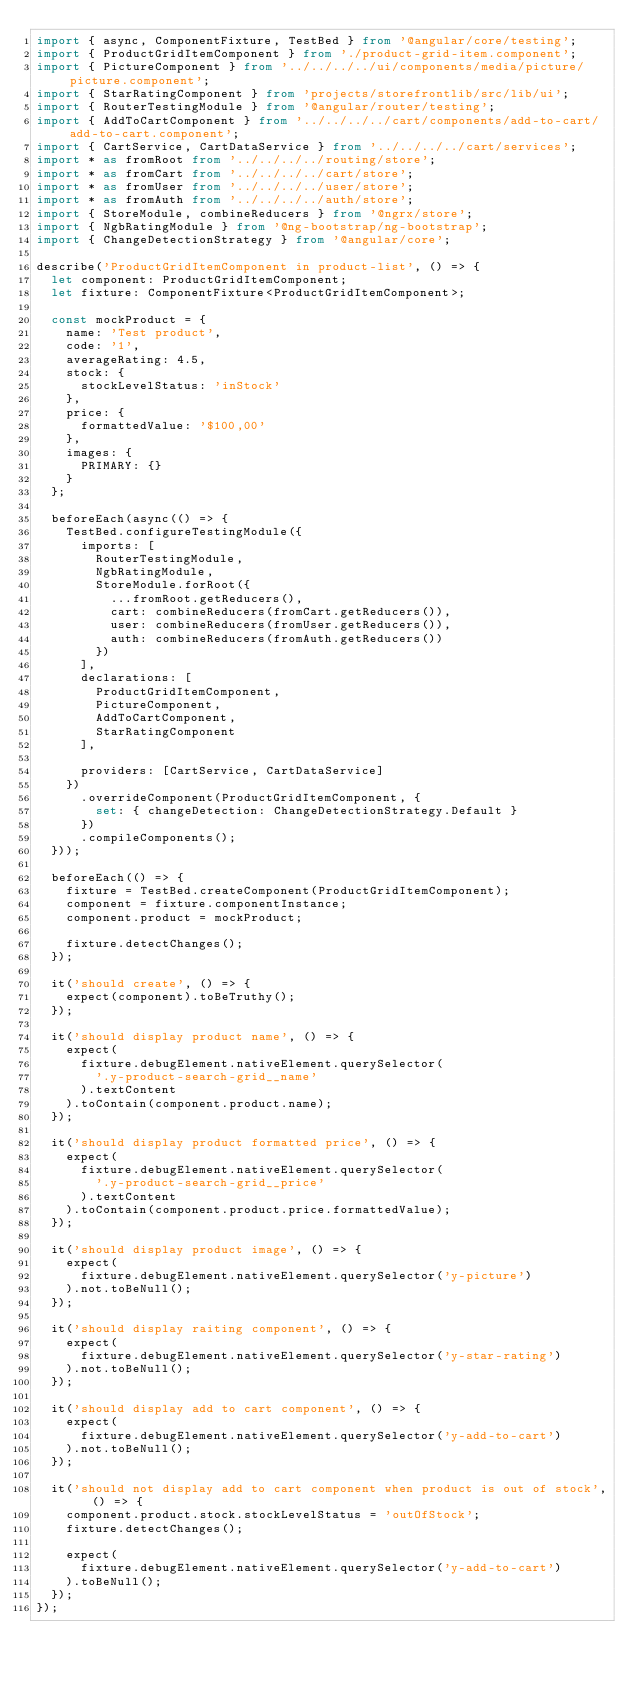<code> <loc_0><loc_0><loc_500><loc_500><_TypeScript_>import { async, ComponentFixture, TestBed } from '@angular/core/testing';
import { ProductGridItemComponent } from './product-grid-item.component';
import { PictureComponent } from '../../../../ui/components/media/picture/picture.component';
import { StarRatingComponent } from 'projects/storefrontlib/src/lib/ui';
import { RouterTestingModule } from '@angular/router/testing';
import { AddToCartComponent } from '../../../../cart/components/add-to-cart/add-to-cart.component';
import { CartService, CartDataService } from '../../../../cart/services';
import * as fromRoot from '../../../../routing/store';
import * as fromCart from '../../../../cart/store';
import * as fromUser from '../../../../user/store';
import * as fromAuth from '../../../../auth/store';
import { StoreModule, combineReducers } from '@ngrx/store';
import { NgbRatingModule } from '@ng-bootstrap/ng-bootstrap';
import { ChangeDetectionStrategy } from '@angular/core';

describe('ProductGridItemComponent in product-list', () => {
  let component: ProductGridItemComponent;
  let fixture: ComponentFixture<ProductGridItemComponent>;

  const mockProduct = {
    name: 'Test product',
    code: '1',
    averageRating: 4.5,
    stock: {
      stockLevelStatus: 'inStock'
    },
    price: {
      formattedValue: '$100,00'
    },
    images: {
      PRIMARY: {}
    }
  };

  beforeEach(async(() => {
    TestBed.configureTestingModule({
      imports: [
        RouterTestingModule,
        NgbRatingModule,
        StoreModule.forRoot({
          ...fromRoot.getReducers(),
          cart: combineReducers(fromCart.getReducers()),
          user: combineReducers(fromUser.getReducers()),
          auth: combineReducers(fromAuth.getReducers())
        })
      ],
      declarations: [
        ProductGridItemComponent,
        PictureComponent,
        AddToCartComponent,
        StarRatingComponent
      ],

      providers: [CartService, CartDataService]
    })
      .overrideComponent(ProductGridItemComponent, {
        set: { changeDetection: ChangeDetectionStrategy.Default }
      })
      .compileComponents();
  }));

  beforeEach(() => {
    fixture = TestBed.createComponent(ProductGridItemComponent);
    component = fixture.componentInstance;
    component.product = mockProduct;

    fixture.detectChanges();
  });

  it('should create', () => {
    expect(component).toBeTruthy();
  });

  it('should display product name', () => {
    expect(
      fixture.debugElement.nativeElement.querySelector(
        '.y-product-search-grid__name'
      ).textContent
    ).toContain(component.product.name);
  });

  it('should display product formatted price', () => {
    expect(
      fixture.debugElement.nativeElement.querySelector(
        '.y-product-search-grid__price'
      ).textContent
    ).toContain(component.product.price.formattedValue);
  });

  it('should display product image', () => {
    expect(
      fixture.debugElement.nativeElement.querySelector('y-picture')
    ).not.toBeNull();
  });

  it('should display raiting component', () => {
    expect(
      fixture.debugElement.nativeElement.querySelector('y-star-rating')
    ).not.toBeNull();
  });

  it('should display add to cart component', () => {
    expect(
      fixture.debugElement.nativeElement.querySelector('y-add-to-cart')
    ).not.toBeNull();
  });

  it('should not display add to cart component when product is out of stock', () => {
    component.product.stock.stockLevelStatus = 'outOfStock';
    fixture.detectChanges();

    expect(
      fixture.debugElement.nativeElement.querySelector('y-add-to-cart')
    ).toBeNull();
  });
});
</code> 